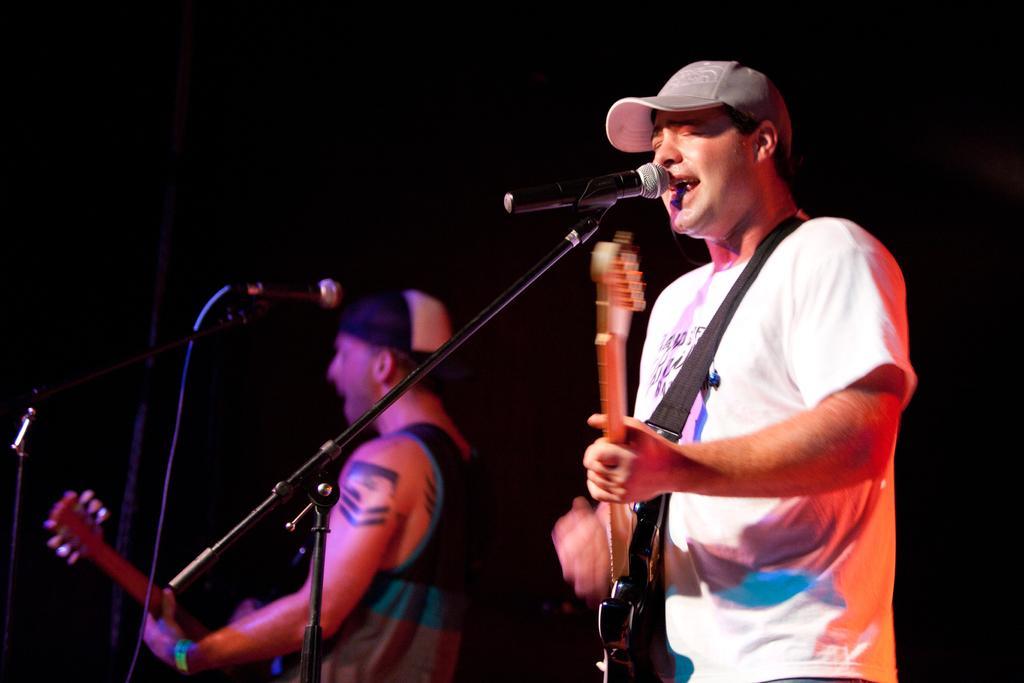How would you summarize this image in a sentence or two? There are two people standing and playing guitars. This is the mic attached to the mike stand. And the background looks dark. 